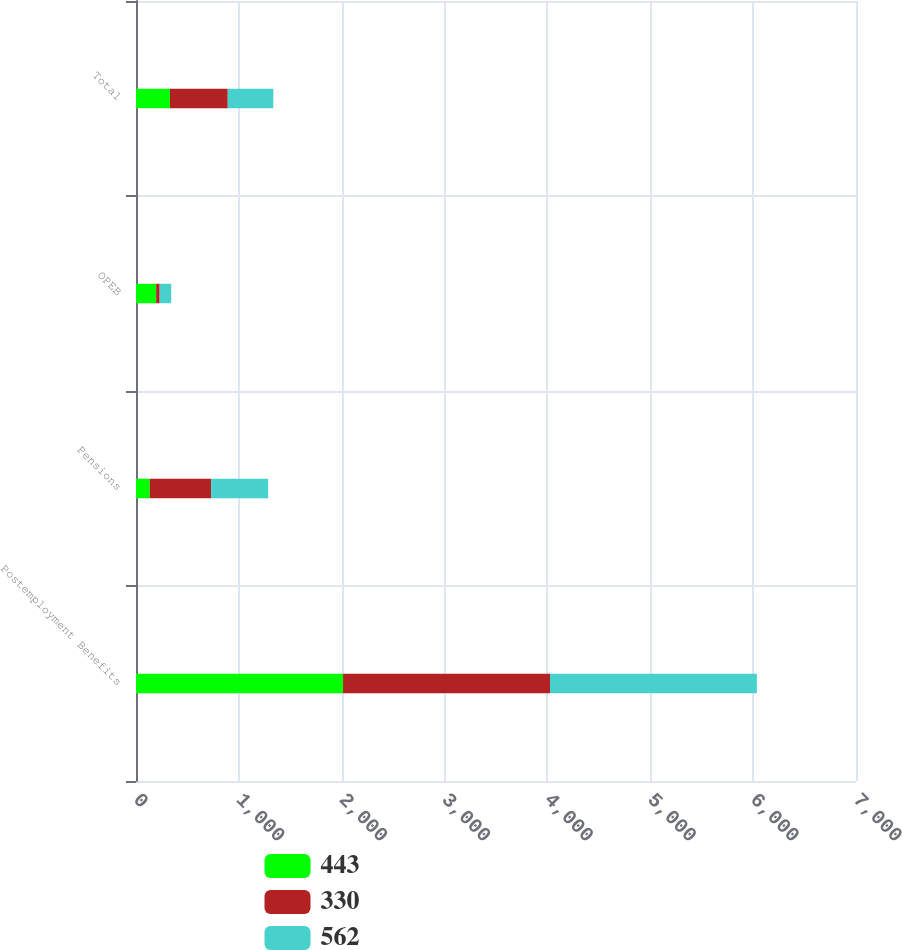<chart> <loc_0><loc_0><loc_500><loc_500><stacked_bar_chart><ecel><fcel>Postemployment Benefits<fcel>Pensions<fcel>OPEB<fcel>Total<nl><fcel>443<fcel>2013<fcel>134<fcel>196<fcel>330<nl><fcel>330<fcel>2012<fcel>596<fcel>34<fcel>562<nl><fcel>562<fcel>2011<fcel>555<fcel>112<fcel>443<nl></chart> 